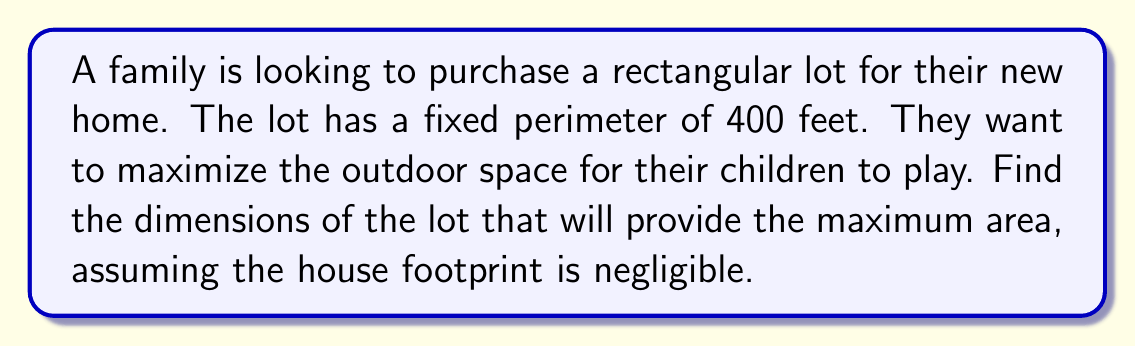Show me your answer to this math problem. Let's approach this step-by-step:

1) Let the width of the lot be $x$ feet and the length be $y$ feet.

2) Given that the perimeter is 400 feet, we can write:
   $$2x + 2y = 400$$

3) Solving for $y$:
   $$y = 200 - x$$

4) The area of the lot, $A$, is given by:
   $$A = xy = x(200-x) = 200x - x^2$$

5) To find the maximum area, we need to find the value of $x$ where $\frac{dA}{dx} = 0$:
   $$\frac{dA}{dx} = 200 - 2x$$

6) Setting this equal to zero:
   $$200 - 2x = 0$$
   $$2x = 200$$
   $$x = 100$$

7) Since $\frac{d^2A}{dx^2} = -2 < 0$, this critical point is a maximum.

8) With $x = 100$, we can find $y$:
   $$y = 200 - x = 200 - 100 = 100$$

9) Therefore, the optimal dimensions are 100 feet by 100 feet.

10) The maximum area is:
    $$A = 100 * 100 = 10,000$$ square feet
Answer: 100 feet by 100 feet, with a maximum area of 10,000 square feet 